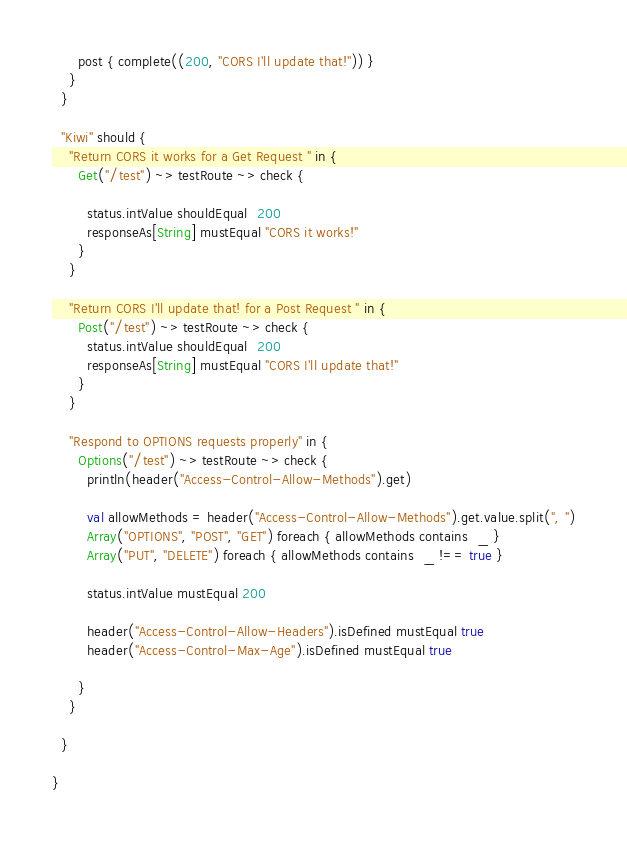<code> <loc_0><loc_0><loc_500><loc_500><_Scala_>      post { complete((200, "CORS I'll update that!")) }
    }
  }

  "Kiwi" should {
    "Return CORS it works for a Get Request " in {
      Get("/test") ~> testRoute ~> check {

        status.intValue shouldEqual  200
        responseAs[String] mustEqual "CORS it works!"
      }
    }

    "Return CORS I'll update that! for a Post Request " in {
      Post("/test") ~> testRoute ~> check {
        status.intValue shouldEqual  200
        responseAs[String] mustEqual "CORS I'll update that!"
      }
    }

    "Respond to OPTIONS requests properly" in {
      Options("/test") ~> testRoute ~> check {
        println(header("Access-Control-Allow-Methods").get)

        val allowMethods = header("Access-Control-Allow-Methods").get.value.split(", ")
        Array("OPTIONS", "POST", "GET") foreach { allowMethods contains  _ }
        Array("PUT", "DELETE") foreach { allowMethods contains  _ !== true }

        status.intValue mustEqual 200

        header("Access-Control-Allow-Headers").isDefined mustEqual true
        header("Access-Control-Max-Age").isDefined mustEqual true

      }
    }

  }

}
</code> 